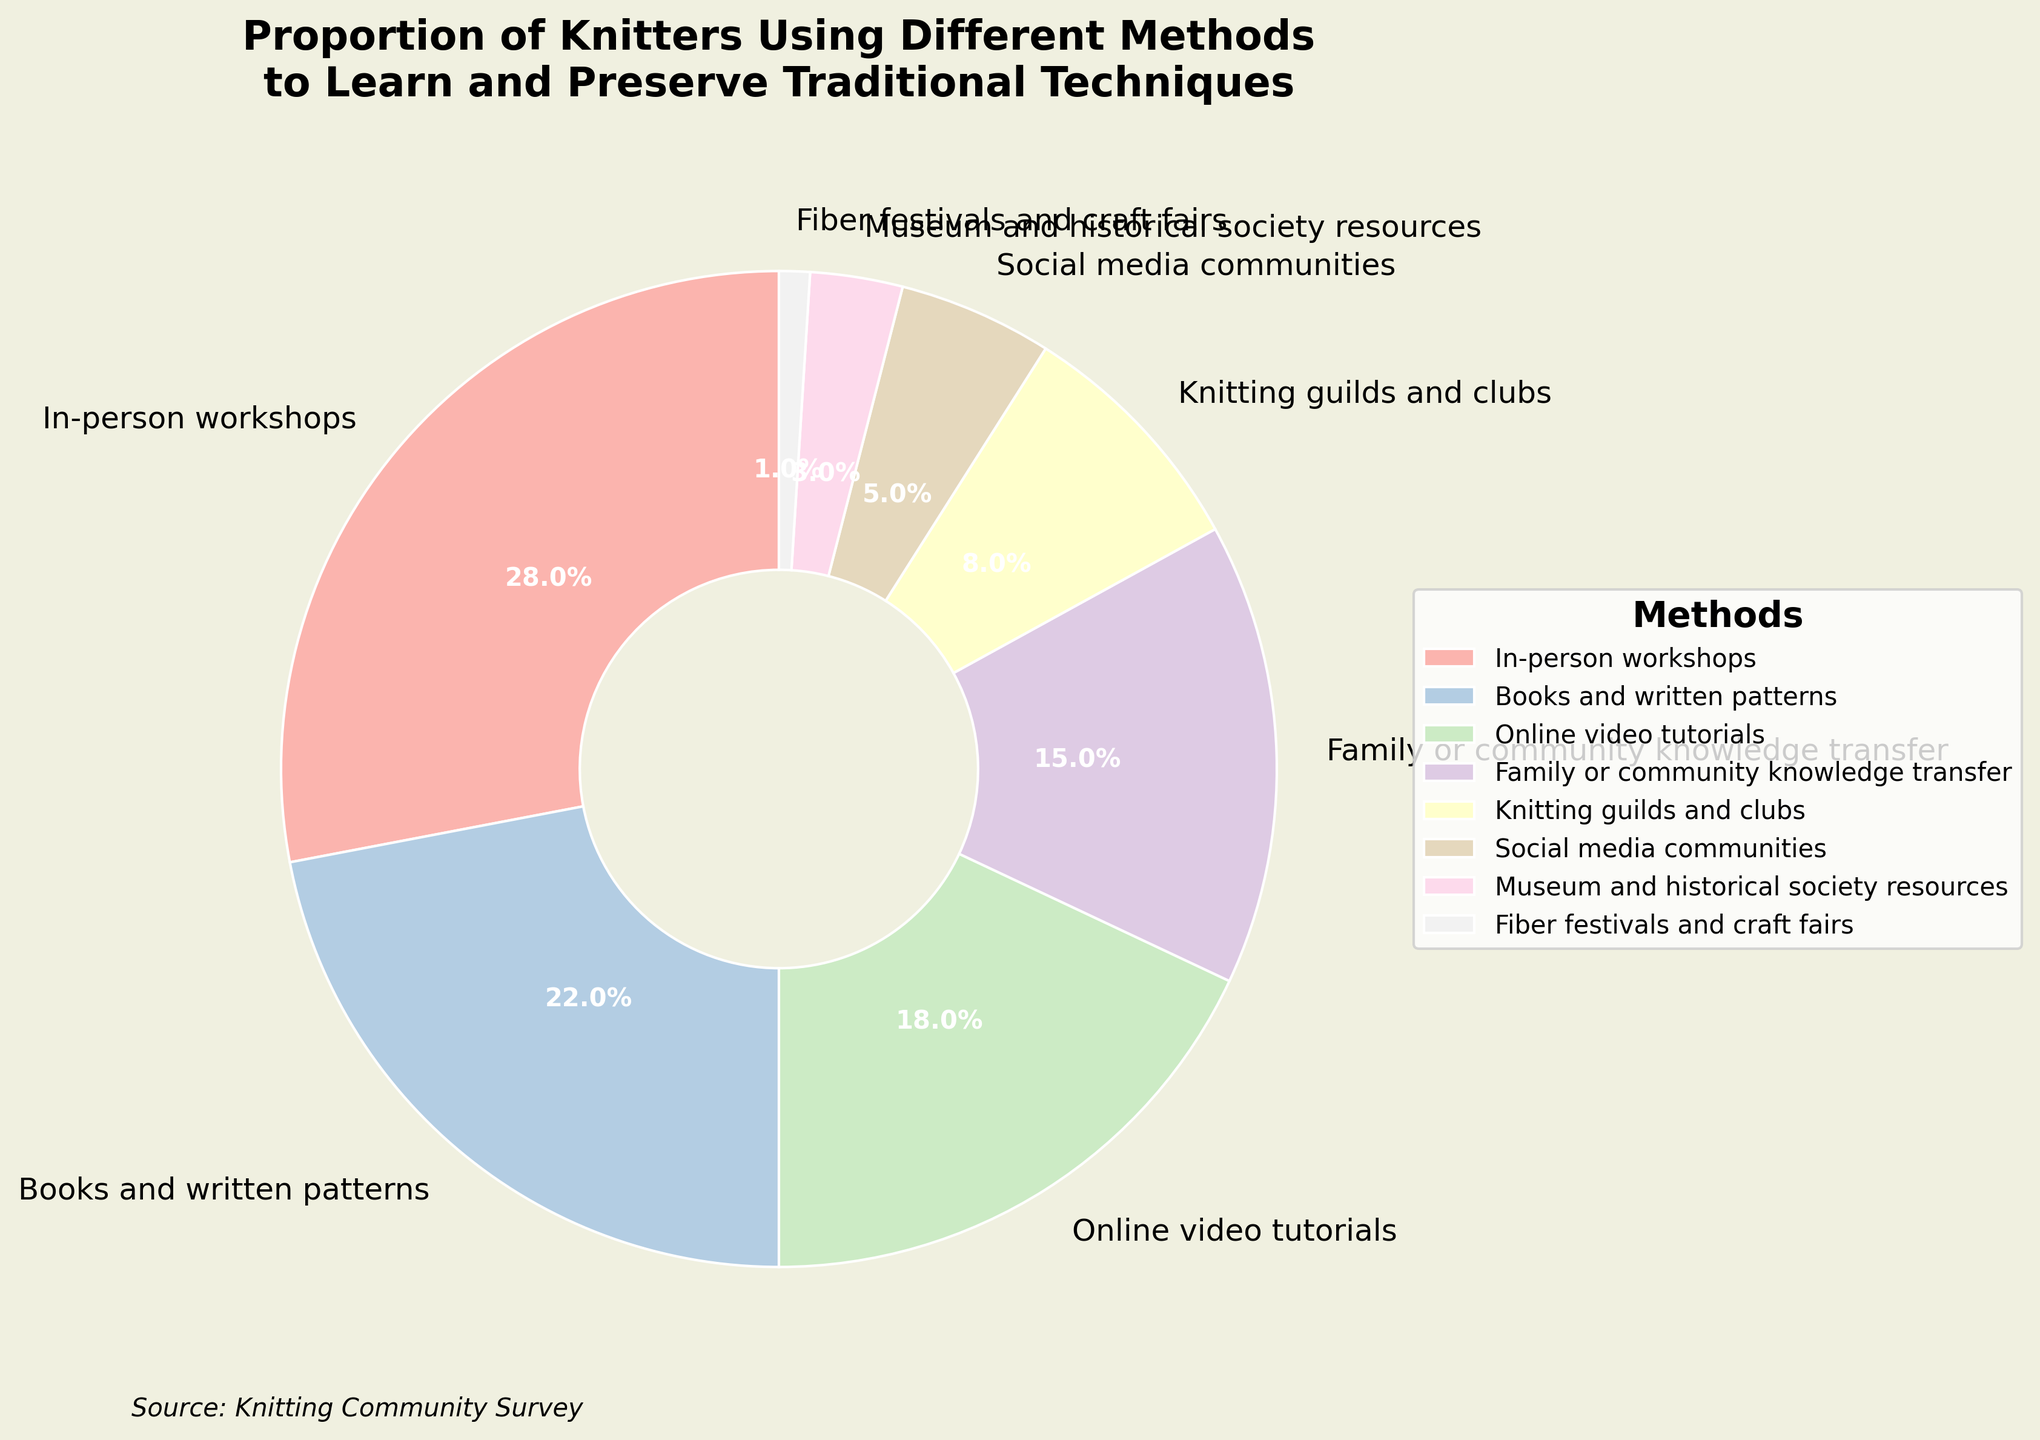What's the most popular method among knitters to learn and preserve traditional techniques? The most popular method is represented by the largest segment of the pie chart. In this case, "In-person workshops" has the largest slice with a percentage of 28%.
Answer: In-person workshops Which method is less popular, online video tutorials or books and written patterns? To determine which method is less popular, compare their percentages. Online video tutorials have 18%, while books and written patterns have 22%.
Answer: Online video tutorials What is the combined percentage of knitters using family or community knowledge transfer and knitting guilds and clubs? Add the percentages of family or community knowledge transfer (15%) and knitting guilds and clubs (8%) together. 15% + 8% = 23%.
Answer: 23% What's the difference in popularity between the most and the least popular methods? Subtract the percentage of the least popular method (Fiber festivals and craft fairs, 1%) from the most popular method (In-person workshops, 28%). 28% - 1% = 27%.
Answer: 27% If you were to combine the three least popular methods, what would their total percentage be? Sum the percentages of the three least popular methods. Museum and historical society resources (3%), Fiber festivals and craft fairs (1%), and Social media communities (5%). 3% + 1% + 5% = 9%.
Answer: 9% What percentage of knitters use books and written patterns or social media communities? Add the percentages of books and written patterns (22%) and social media communities (5%). 22% + 5% = 27%.
Answer: 27% How does the popularity of online video tutorials compare to the popularity of books and written patterns? Compare their percentages directly. Online video tutorials (18%) is less popular than books and written patterns (22%).
Answer: Online video tutorials is less popular Which methods share similar popularity levels, judging by the pie chart? Family or community knowledge transfer (15%) and knitting guilds and clubs (8%) are reasonably close, but the closest are family or community knowledge transfer (15%) and online video tutorials (18%). The gaps between these pairs are - 7% and 3%, respectively.
Answer: Family or community knowledge transfer and online video tutorials Based on the pie chart colors, which methods are represented by the lightest hues? Observing the pie chart, the lightest hues are usually assigned to the smallest segments because they are in the Pastel color palette spread out uniformly. The smallest segments represent Fiber festivals and craft fairs (1%), Museum and historical society resources (3%), and Social media communities (5%).
Answer: Fiber festivals and craft fairs, Museum and historical society resources, Social media communities If you exclude the top two most utilized methods, what percentage of knitters use the remaining methods combined? First, identify the top two methods (In-person workshops 28%, Books and written patterns 22%). Subtract their combined percentage from 100%. 100% - (28% + 22%) = 50%.
Answer: 50% 